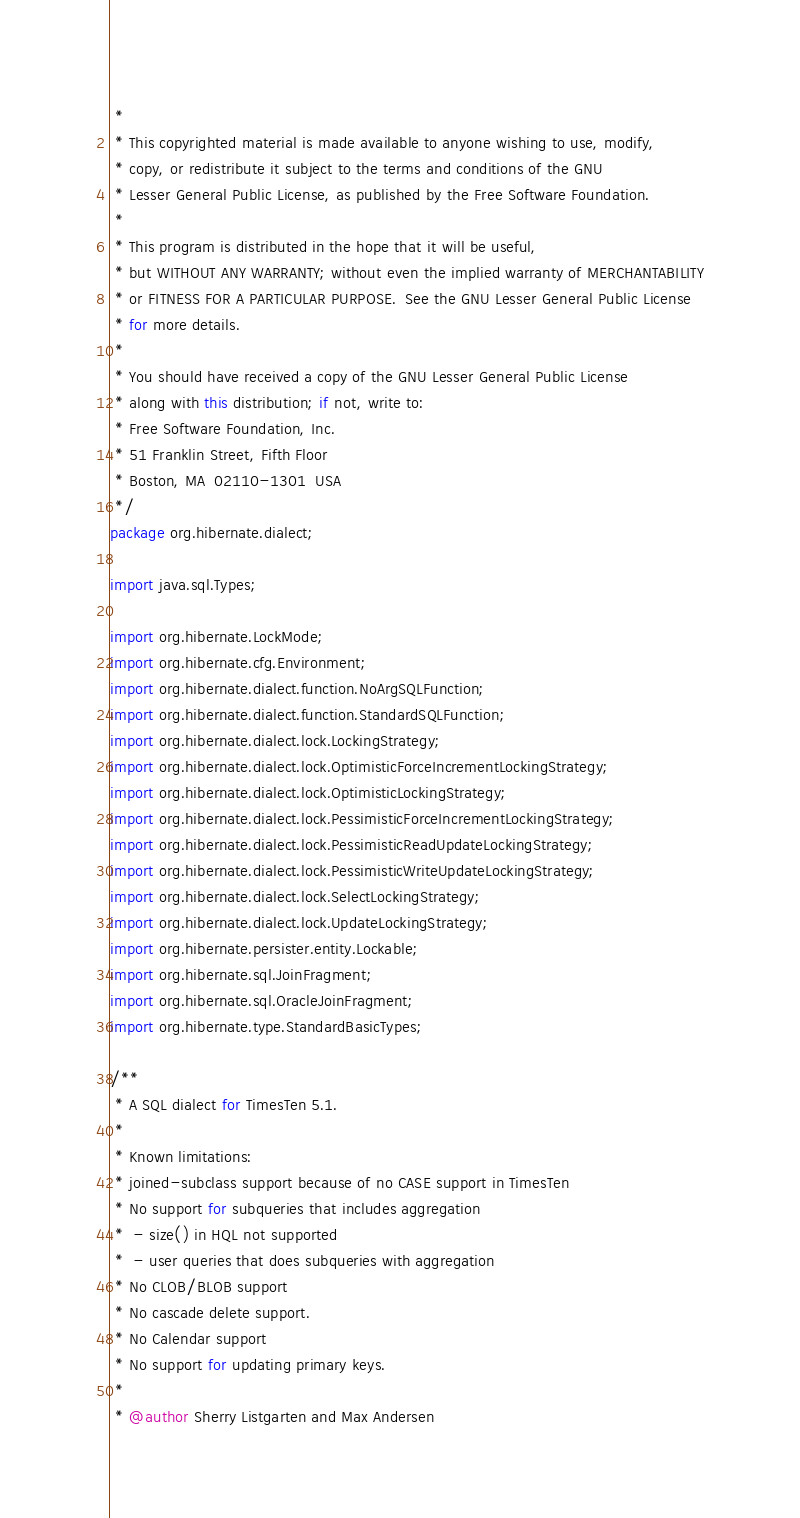<code> <loc_0><loc_0><loc_500><loc_500><_Java_> *
 * This copyrighted material is made available to anyone wishing to use, modify,
 * copy, or redistribute it subject to the terms and conditions of the GNU
 * Lesser General Public License, as published by the Free Software Foundation.
 *
 * This program is distributed in the hope that it will be useful,
 * but WITHOUT ANY WARRANTY; without even the implied warranty of MERCHANTABILITY
 * or FITNESS FOR A PARTICULAR PURPOSE.  See the GNU Lesser General Public License
 * for more details.
 *
 * You should have received a copy of the GNU Lesser General Public License
 * along with this distribution; if not, write to:
 * Free Software Foundation, Inc.
 * 51 Franklin Street, Fifth Floor
 * Boston, MA  02110-1301  USA
 */
package org.hibernate.dialect;

import java.sql.Types;

import org.hibernate.LockMode;
import org.hibernate.cfg.Environment;
import org.hibernate.dialect.function.NoArgSQLFunction;
import org.hibernate.dialect.function.StandardSQLFunction;
import org.hibernate.dialect.lock.LockingStrategy;
import org.hibernate.dialect.lock.OptimisticForceIncrementLockingStrategy;
import org.hibernate.dialect.lock.OptimisticLockingStrategy;
import org.hibernate.dialect.lock.PessimisticForceIncrementLockingStrategy;
import org.hibernate.dialect.lock.PessimisticReadUpdateLockingStrategy;
import org.hibernate.dialect.lock.PessimisticWriteUpdateLockingStrategy;
import org.hibernate.dialect.lock.SelectLockingStrategy;
import org.hibernate.dialect.lock.UpdateLockingStrategy;
import org.hibernate.persister.entity.Lockable;
import org.hibernate.sql.JoinFragment;
import org.hibernate.sql.OracleJoinFragment;
import org.hibernate.type.StandardBasicTypes;

/**
 * A SQL dialect for TimesTen 5.1.
 * 
 * Known limitations:
 * joined-subclass support because of no CASE support in TimesTen
 * No support for subqueries that includes aggregation
 *  - size() in HQL not supported
 *  - user queries that does subqueries with aggregation
 * No CLOB/BLOB support 
 * No cascade delete support.
 * No Calendar support
 * No support for updating primary keys.
 * 
 * @author Sherry Listgarten and Max Andersen</code> 